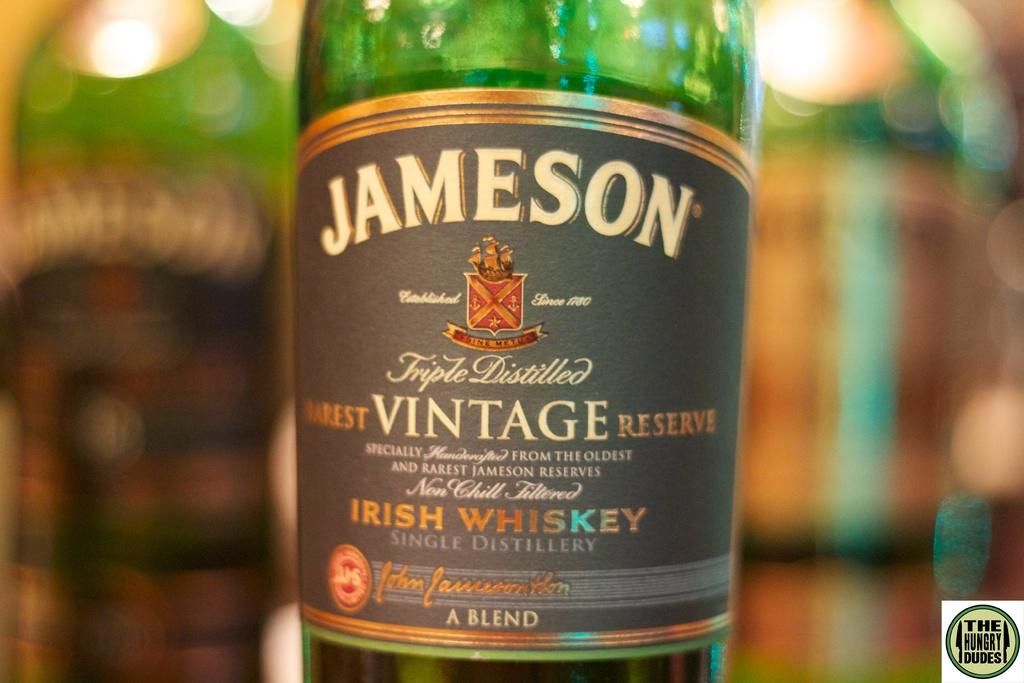<image>
Describe the image concisely. A shot of the label of a Jameson Triple Distilled Irish Whiskey bottle. 